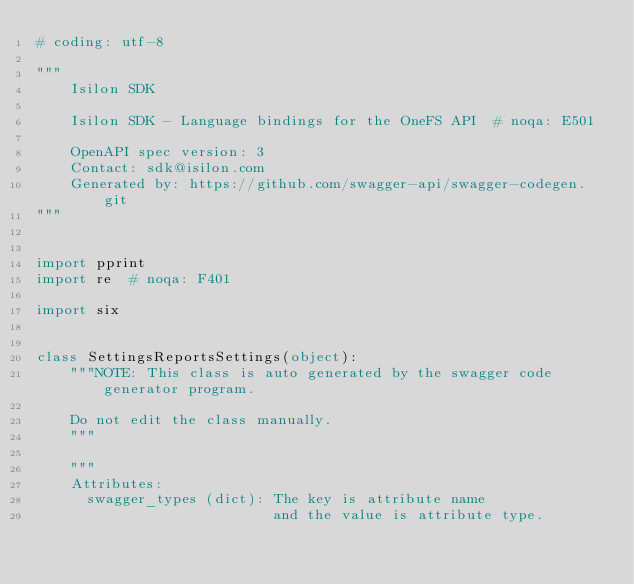Convert code to text. <code><loc_0><loc_0><loc_500><loc_500><_Python_># coding: utf-8

"""
    Isilon SDK

    Isilon SDK - Language bindings for the OneFS API  # noqa: E501

    OpenAPI spec version: 3
    Contact: sdk@isilon.com
    Generated by: https://github.com/swagger-api/swagger-codegen.git
"""


import pprint
import re  # noqa: F401

import six


class SettingsReportsSettings(object):
    """NOTE: This class is auto generated by the swagger code generator program.

    Do not edit the class manually.
    """

    """
    Attributes:
      swagger_types (dict): The key is attribute name
                            and the value is attribute type.</code> 